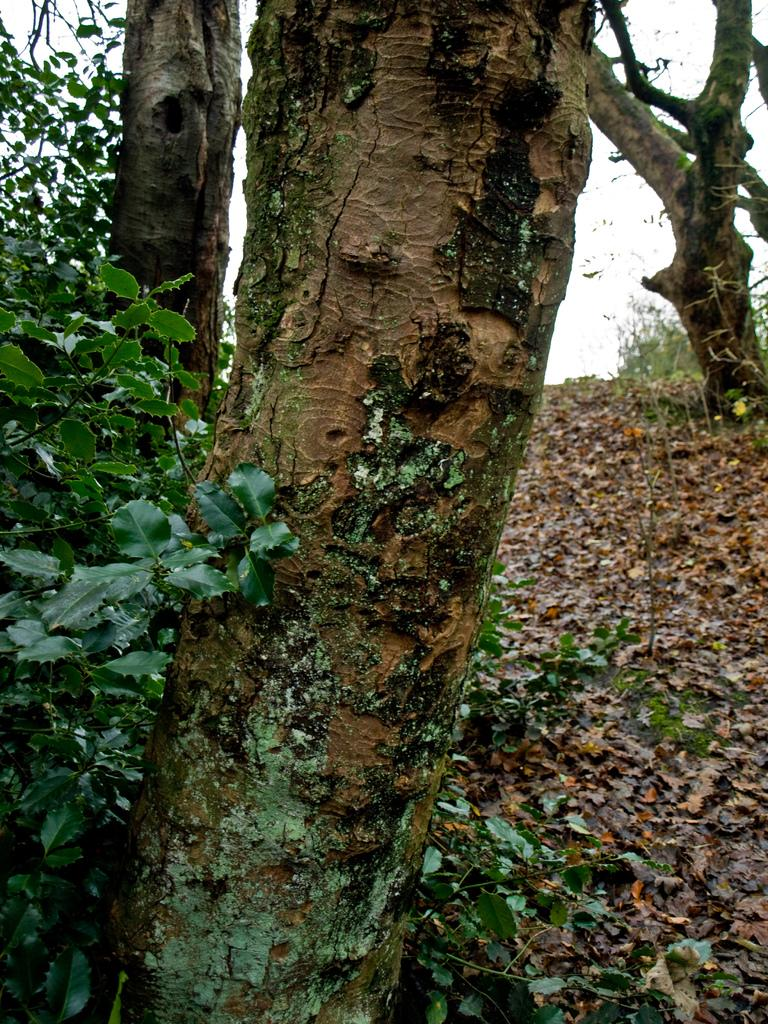What type of natural elements can be seen in the image? There are tree trunks and plants in the image. What part of the natural environment is visible in the image? The sky is visible in the image. What is present on the path in the image? There are dry leaves on the path in the image. What type of crime is being committed in the image? There is no indication of any crime being committed in the image; it features tree trunks, plants, the sky, and dry leaves on a path. 